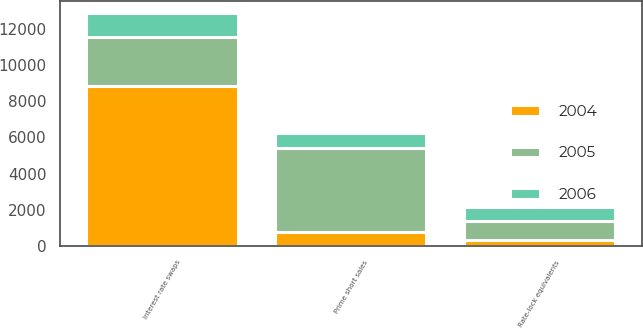Convert chart to OTSL. <chart><loc_0><loc_0><loc_500><loc_500><stacked_bar_chart><ecel><fcel>Interest rate swaps<fcel>Rate-lock equivalents<fcel>Prime short sales<nl><fcel>2004<fcel>8831<fcel>317<fcel>777<nl><fcel>2006<fcel>1325<fcel>801<fcel>805<nl><fcel>2005<fcel>2703<fcel>1065<fcel>4663<nl></chart> 